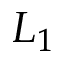Convert formula to latex. <formula><loc_0><loc_0><loc_500><loc_500>L _ { 1 }</formula> 